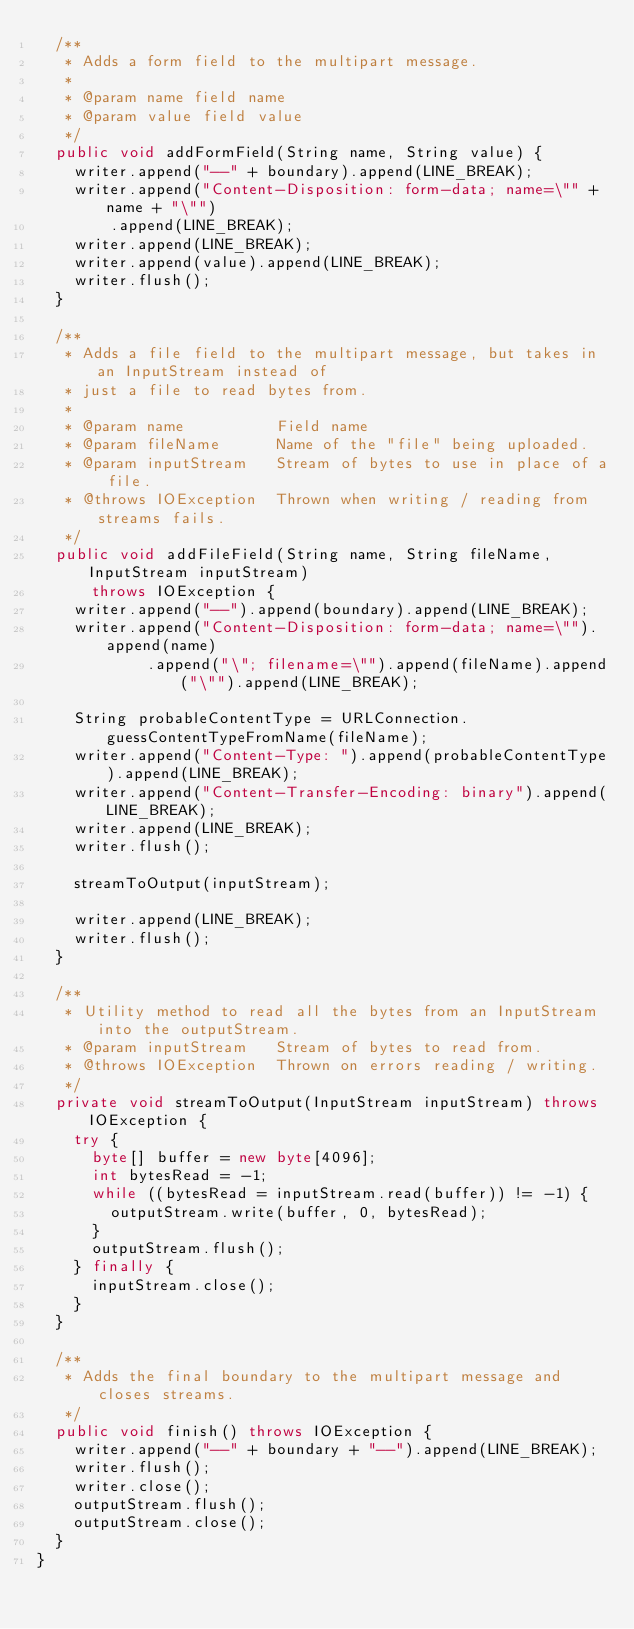Convert code to text. <code><loc_0><loc_0><loc_500><loc_500><_Java_>  /**
   * Adds a form field to the multipart message.
   *
   * @param name field name
   * @param value field value
   */
  public void addFormField(String name, String value) {
    writer.append("--" + boundary).append(LINE_BREAK);
    writer.append("Content-Disposition: form-data; name=\"" + name + "\"")
        .append(LINE_BREAK);
    writer.append(LINE_BREAK);
    writer.append(value).append(LINE_BREAK);
    writer.flush();
  }

  /**
   * Adds a file field to the multipart message, but takes in an InputStream instead of
   * just a file to read bytes from.
   *
   * @param name          Field name
   * @param fileName      Name of the "file" being uploaded.
   * @param inputStream   Stream of bytes to use in place of a file.
   * @throws IOException  Thrown when writing / reading from streams fails.
   */
  public void addFileField(String name, String fileName, InputStream inputStream)
      throws IOException {
    writer.append("--").append(boundary).append(LINE_BREAK);
    writer.append("Content-Disposition: form-data; name=\"").append(name)
            .append("\"; filename=\"").append(fileName).append("\"").append(LINE_BREAK);

    String probableContentType = URLConnection.guessContentTypeFromName(fileName);
    writer.append("Content-Type: ").append(probableContentType).append(LINE_BREAK);
    writer.append("Content-Transfer-Encoding: binary").append(LINE_BREAK);
    writer.append(LINE_BREAK);
    writer.flush();

    streamToOutput(inputStream);

    writer.append(LINE_BREAK);
    writer.flush();
  }

  /**
   * Utility method to read all the bytes from an InputStream into the outputStream.
   * @param inputStream   Stream of bytes to read from.
   * @throws IOException  Thrown on errors reading / writing.
   */
  private void streamToOutput(InputStream inputStream) throws IOException {
    try {
      byte[] buffer = new byte[4096];
      int bytesRead = -1;
      while ((bytesRead = inputStream.read(buffer)) != -1) {
        outputStream.write(buffer, 0, bytesRead);
      }
      outputStream.flush();
    } finally {
      inputStream.close();
    }
  }

  /**
   * Adds the final boundary to the multipart message and closes streams.
   */
  public void finish() throws IOException {
    writer.append("--" + boundary + "--").append(LINE_BREAK);
    writer.flush();
    writer.close();
    outputStream.flush();
    outputStream.close();
  }
}
</code> 